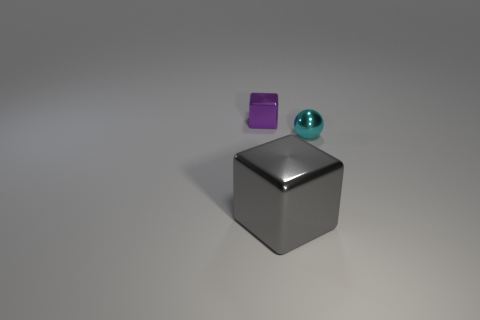What color is the metallic cube that is behind the cube in front of the purple metallic object?
Ensure brevity in your answer.  Purple. Are there an equal number of big metallic objects to the left of the tiny cyan object and gray metallic cubes that are behind the gray shiny thing?
Your response must be concise. No. Is the block that is to the right of the tiny purple block made of the same material as the tiny purple thing?
Give a very brief answer. Yes. What is the color of the metal object that is both left of the cyan metallic ball and right of the tiny purple shiny object?
Make the answer very short. Gray. There is a cube in front of the purple object; what number of tiny purple blocks are in front of it?
Your response must be concise. 0. There is a large gray thing that is the same shape as the purple shiny thing; what material is it?
Provide a short and direct response. Metal. The tiny block is what color?
Make the answer very short. Purple. What number of things are either tiny blocks or big yellow shiny cylinders?
Provide a succinct answer. 1. The metallic thing that is on the left side of the cube in front of the small purple object is what shape?
Provide a short and direct response. Cube. How many other objects are the same material as the tiny cyan thing?
Give a very brief answer. 2. 